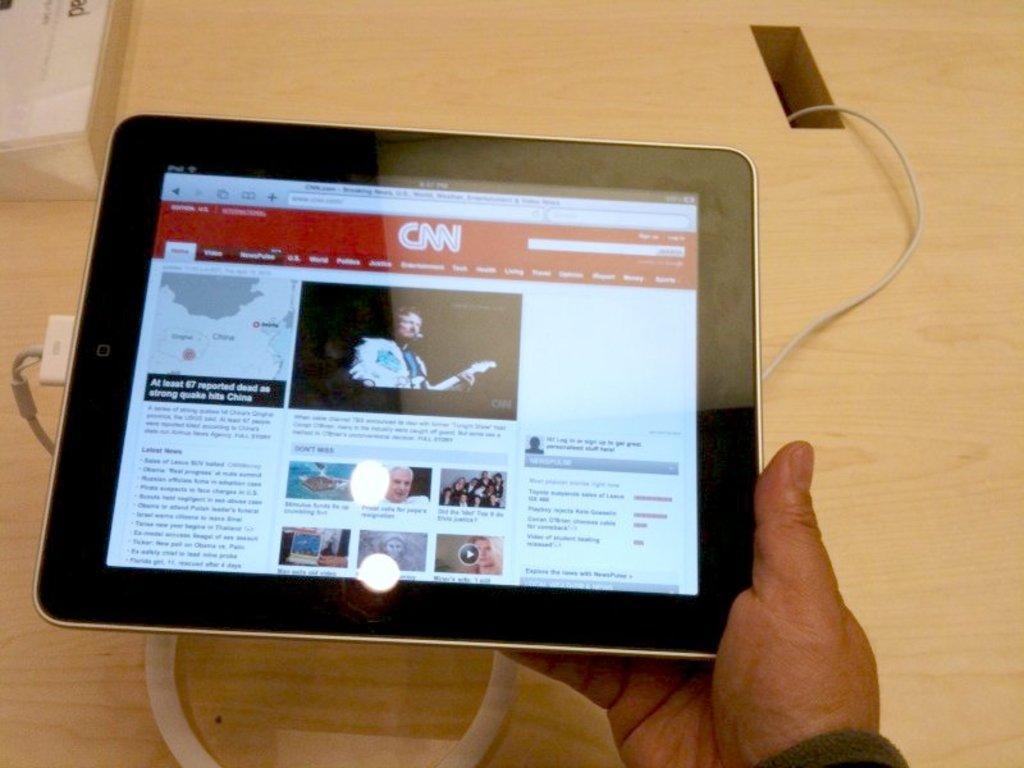Describe this image in one or two sentences. In this image we can see there is a person's hand and he is holding a tablet, which is placed on the table and a cable connected to it. 